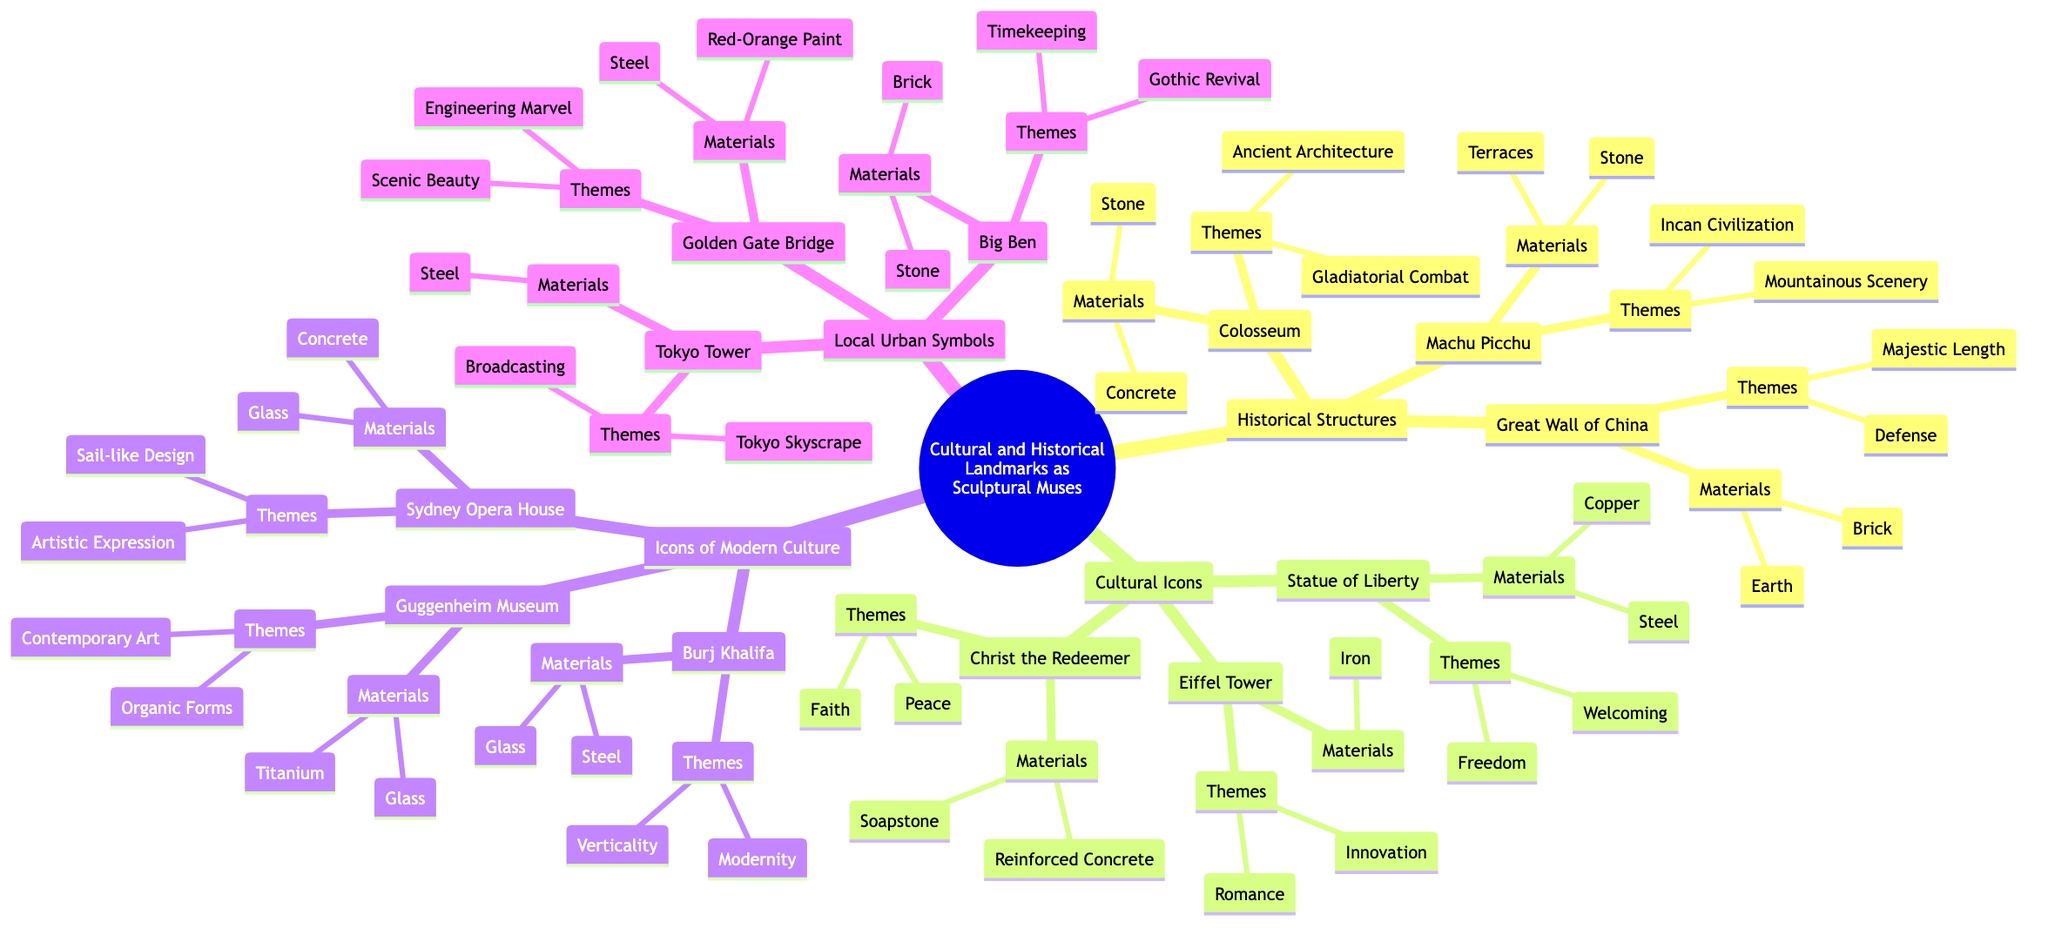What historical structure is associated with "Gladiatorial Combat"? The diagram shows that the Colosseum, under the Historical Structures category, is specifically linked with the theme of "Gladiatorial Combat."
Answer: Colosseum How many themes are listed for the Statue of Liberty? By looking at the Statue of Liberty node within the Cultural Icons section, it lists two themes: "Freedom" and "Welcoming."
Answer: 2 Which iconic cultural landmark uses Steel as a material? From the diagram, we can see that the Statue of Liberty, Eiffel Tower, Christ the Redeemer, Sydney Opera House, Burj Khalifa, Guggenheim Museum, Golden Gate Bridge, Big Ben, and Tokyo Tower use various materials, but specifically, both the Statue of Liberty, the Sydney Opera House, Burj Khalifa, Golden Gate Bridge, Big Ben, and Tokyo Tower include Steel.
Answer: Statue of Liberty, Sydney Opera House, Burj Khalifa, Golden Gate Bridge, Big Ben, Tokyo Tower What is the main theme associated with the Great Wall of China? The Great Wall of China under the Historical Structures category has two themes listed: "Defense" and "Majestic Length." It asks for the main theme associated with it. Looking through the themes, "Defense" can be seen as a significant theme.
Answer: Defense How many cultural icons are mentioned in the diagram? From the Cultural Icons section of the diagram, three landmarks are identified: Statue of Liberty, Eiffel Tower, and Christ the Redeemer. Counting these gives a total of three cultural icons mentioned.
Answer: 3 Which landmark features a "Sail-like Design" theme? In the Icons of Modern Culture category, it identifies that the Sydney Opera House has a theme that corresponds to "Sail-like Design," making it the landmark associated with this theme.
Answer: Sydney Opera House What are the materials used for the Guggenheim Museum? Looking at the Guggenheim Museum entry in the Icons of Modern Culture section, the materials listed are "Titanium" and "Glass."
Answer: Titanium, Glass What is a theme related to the Golden Gate Bridge? The Golden Gate Bridge node under Local Urban Symbols presents "Engineering Marvel" and "Scenic Beauty" as its themes. Highlighting the first main theme shows "Engineering Marvel."
Answer: Engineering Marvel How many landmarks are under Icons of Modern Culture? The Icons of Modern Culture category has three landmarks listed: Sydney Opera House, Burj Khalifa, and Guggenheim Museum. This counts up to three landmarks in total.
Answer: 3 